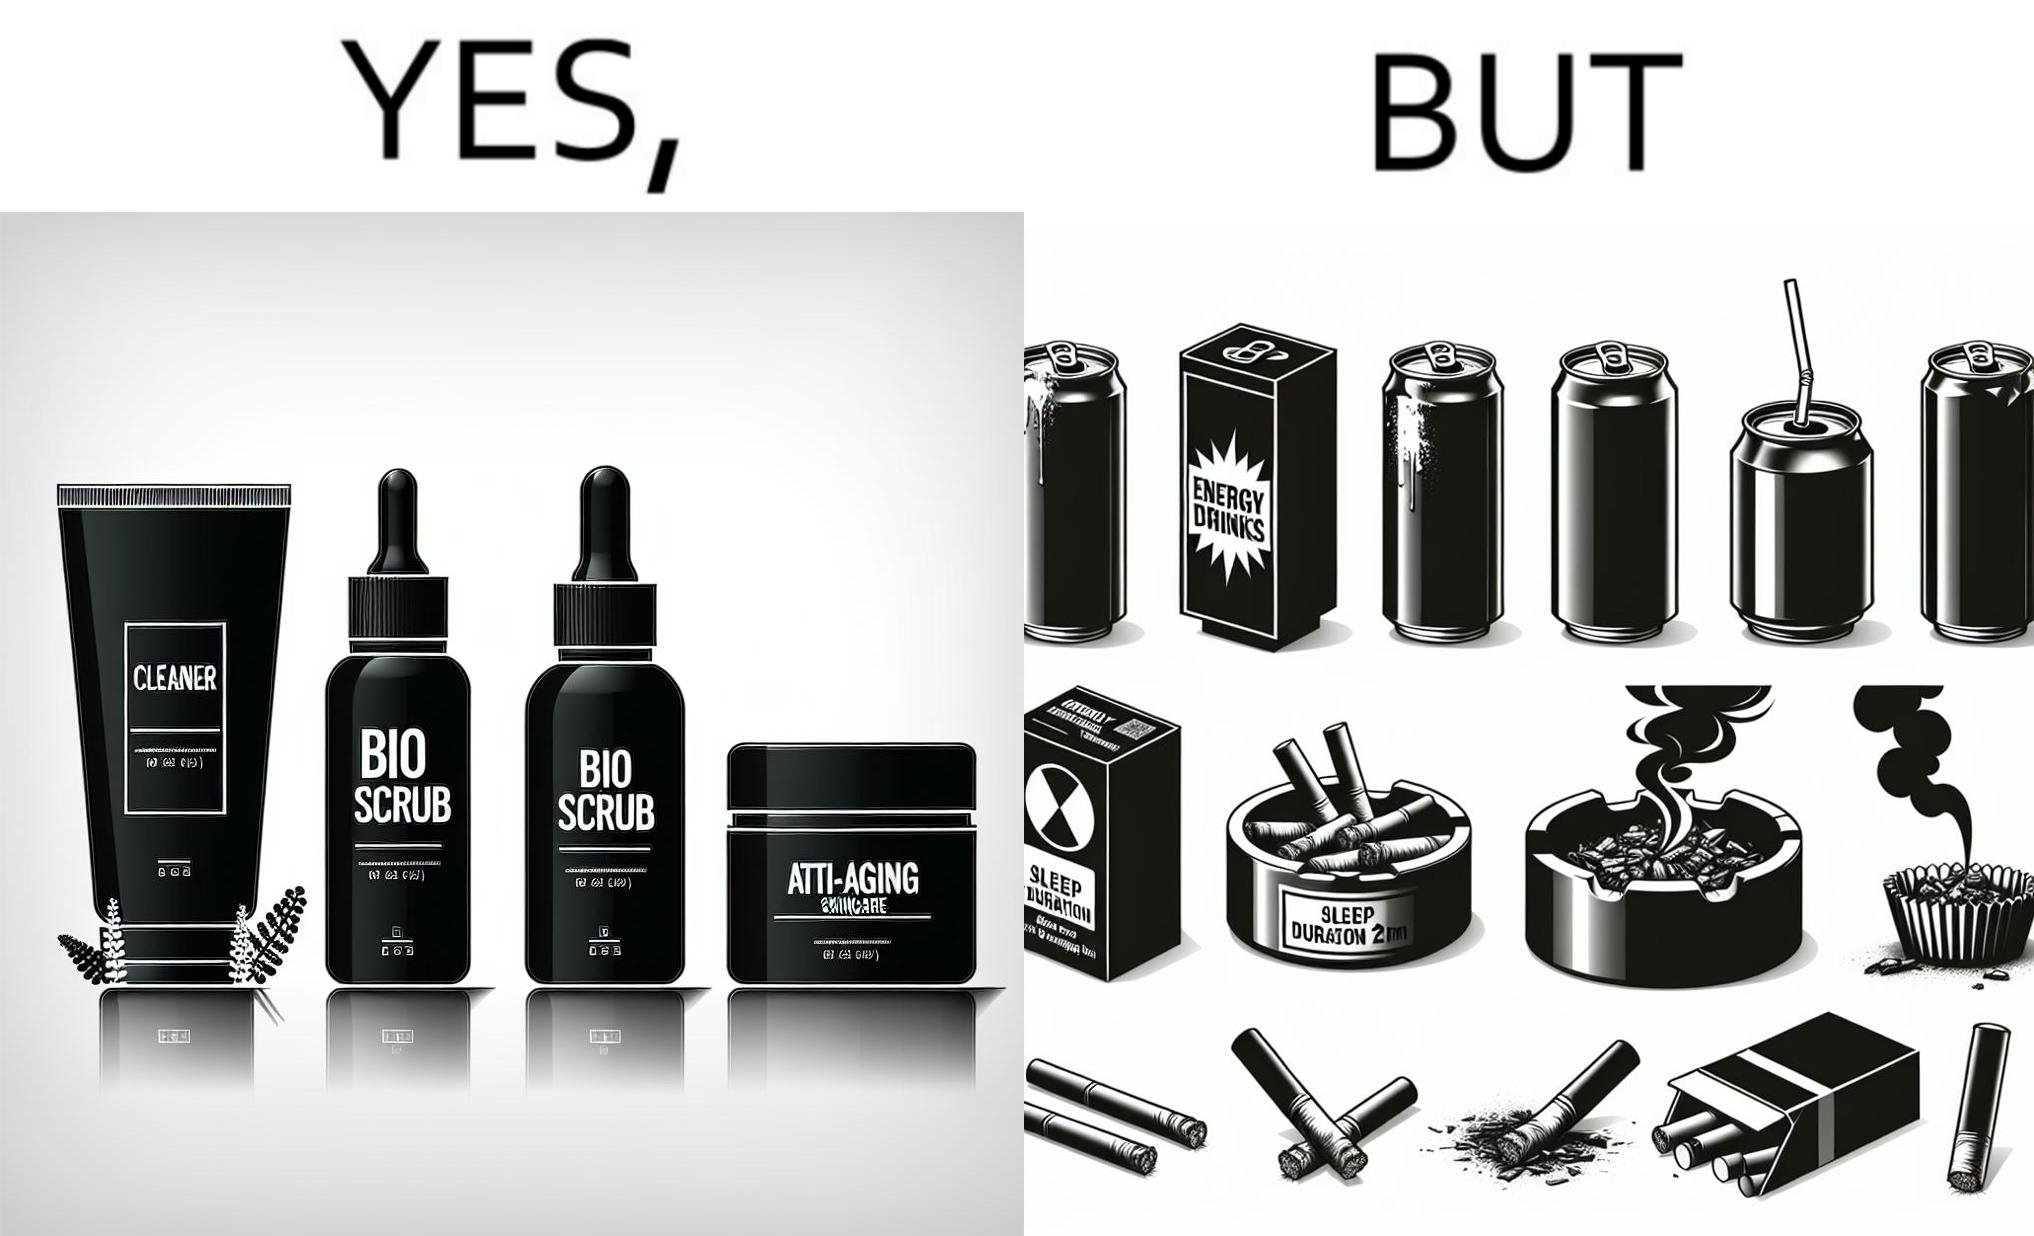Describe the contrast between the left and right parts of this image. In the left part of the image: 4 Skincare products, arranged aesthetically. A tube labeled "Cleaner". A tube labeled "BIO SCRUB". A dropper bottle labeled "HYDRATING GEL". A jar called "ANTI-AGING SKINCARE". In the right part of the image: 9 cans of red bull, some standing upright, some crushed. Cans have blue and red colors. An ashtray with many cigarette butts in it and has smoke coming out. A banner that says "Sleep duration 2h 5min". 